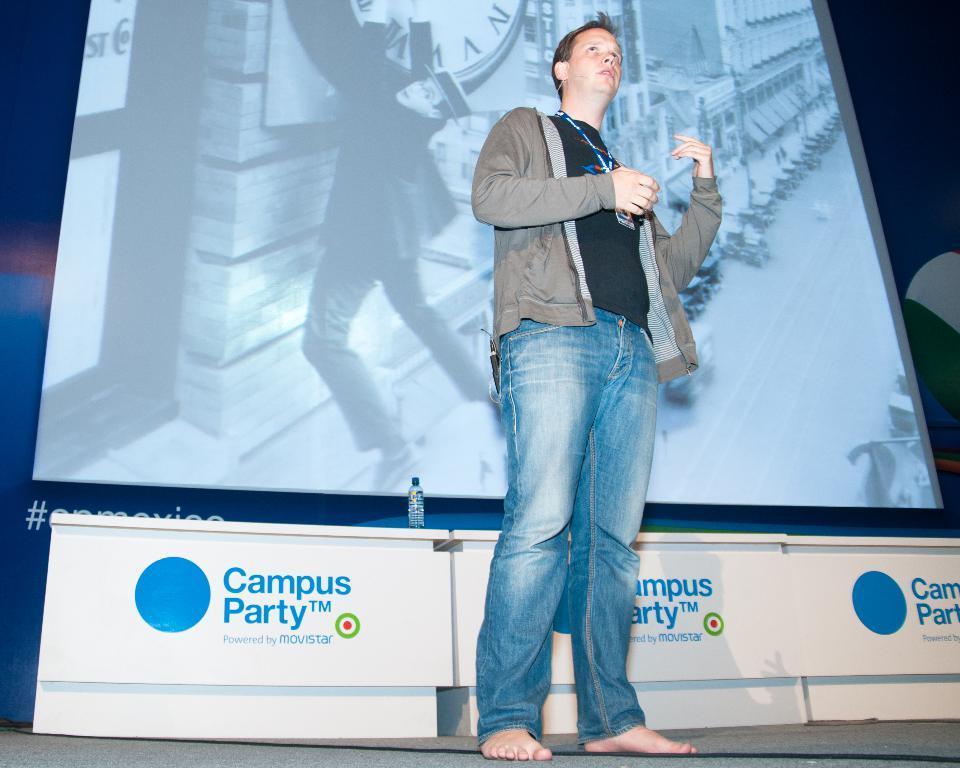Can you describe this image briefly? In the center of this picture we can see a person wearing jacket and standing. In the background we can see the projector screen on which we can see the picture containing a person hanging on the clock and we can see the buildings and some other objects and in the background we can see the tables, a water bottle and we can see the text on the tables. 